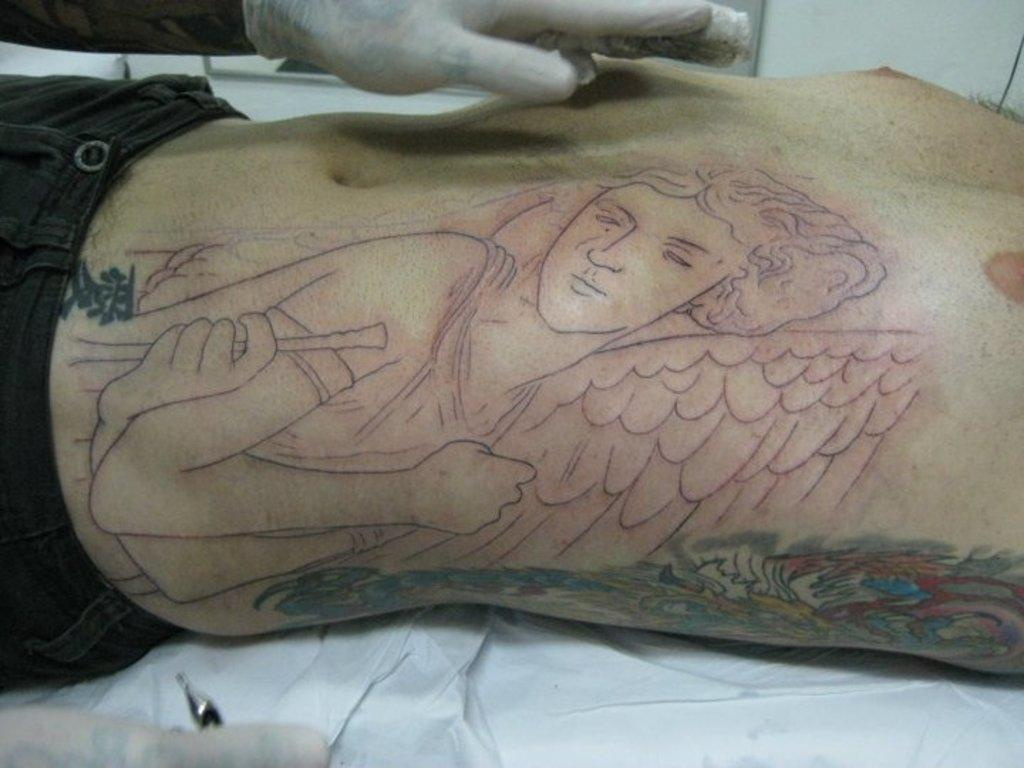Who is present in the image? There is a man in the picture. What is the man doing in the image? The man is lying down. What can be observed on the man's body? The man has tattoos on his body. Whose hand is visible at the top of the picture? There is a person's hand visible at the top of the picture. What type of bucket is being used by the boys in the image? There are no boys or buckets present in the image; it features a man lying down with tattoos and a person's hand visible at the top. 